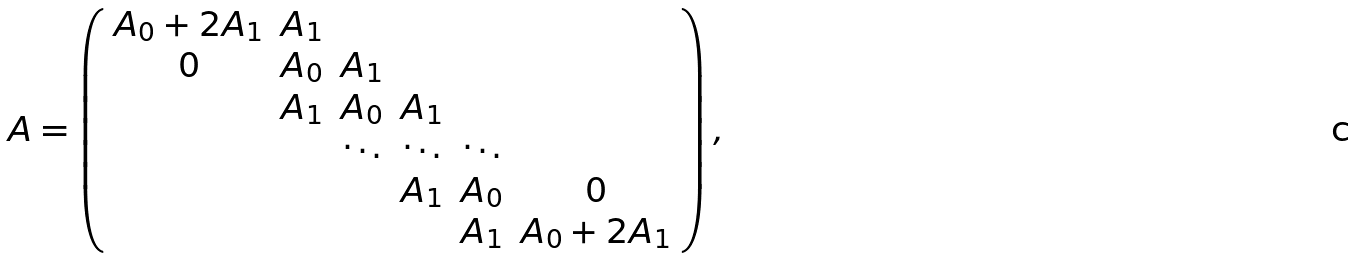<formula> <loc_0><loc_0><loc_500><loc_500>A = \left ( \begin{array} { c c c c c c } A _ { 0 } + 2 A _ { 1 } & A _ { 1 } & & & & \\ 0 & A _ { 0 } & A _ { 1 } & & & \\ & A _ { 1 } & A _ { 0 } & A _ { 1 } & & \\ & & \ddots & \ddots & \ddots & \\ & & & A _ { 1 } & A _ { 0 } & 0 \\ & & & & A _ { 1 } & A _ { 0 } + 2 A _ { 1 } \end{array} \right ) ,</formula> 